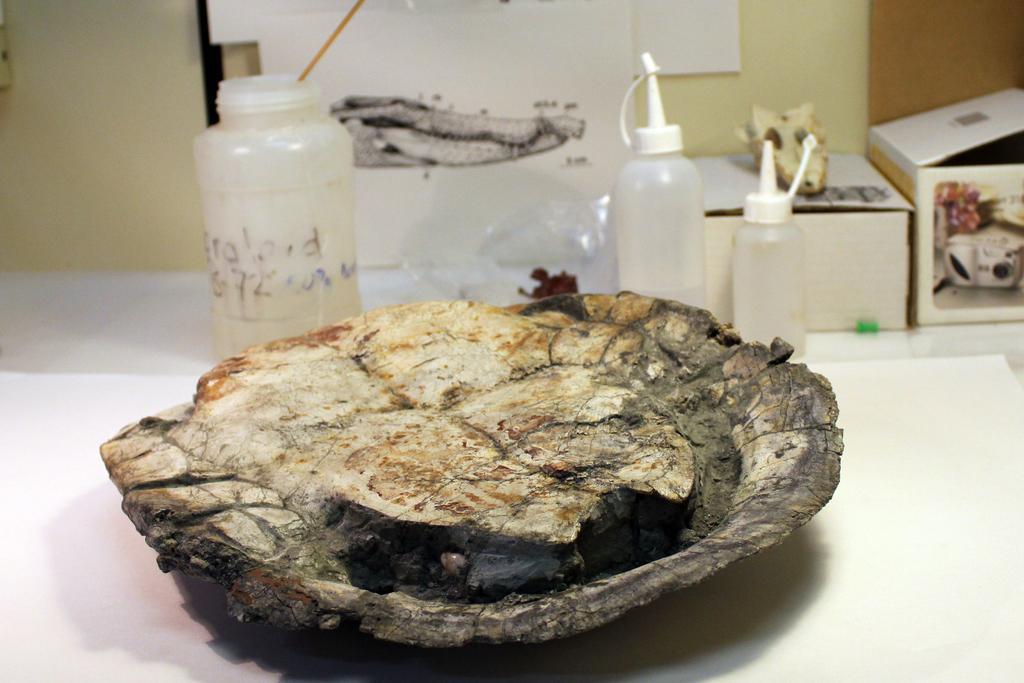Can you describe this image briefly? In the center of the image we can see tortoise placed on the table. In the background we can see bottles, drawing and wall. 